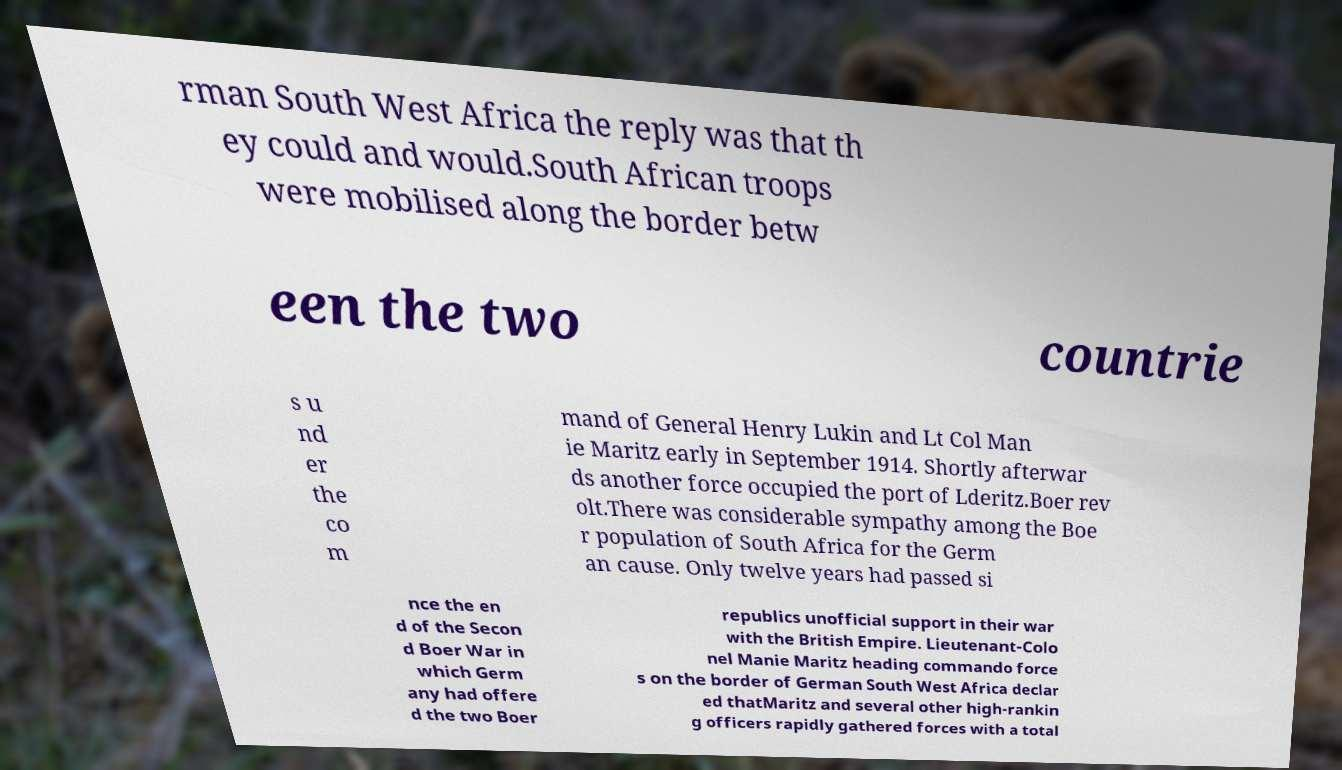For documentation purposes, I need the text within this image transcribed. Could you provide that? rman South West Africa the reply was that th ey could and would.South African troops were mobilised along the border betw een the two countrie s u nd er the co m mand of General Henry Lukin and Lt Col Man ie Maritz early in September 1914. Shortly afterwar ds another force occupied the port of Lderitz.Boer rev olt.There was considerable sympathy among the Boe r population of South Africa for the Germ an cause. Only twelve years had passed si nce the en d of the Secon d Boer War in which Germ any had offere d the two Boer republics unofficial support in their war with the British Empire. Lieutenant-Colo nel Manie Maritz heading commando force s on the border of German South West Africa declar ed thatMaritz and several other high-rankin g officers rapidly gathered forces with a total 